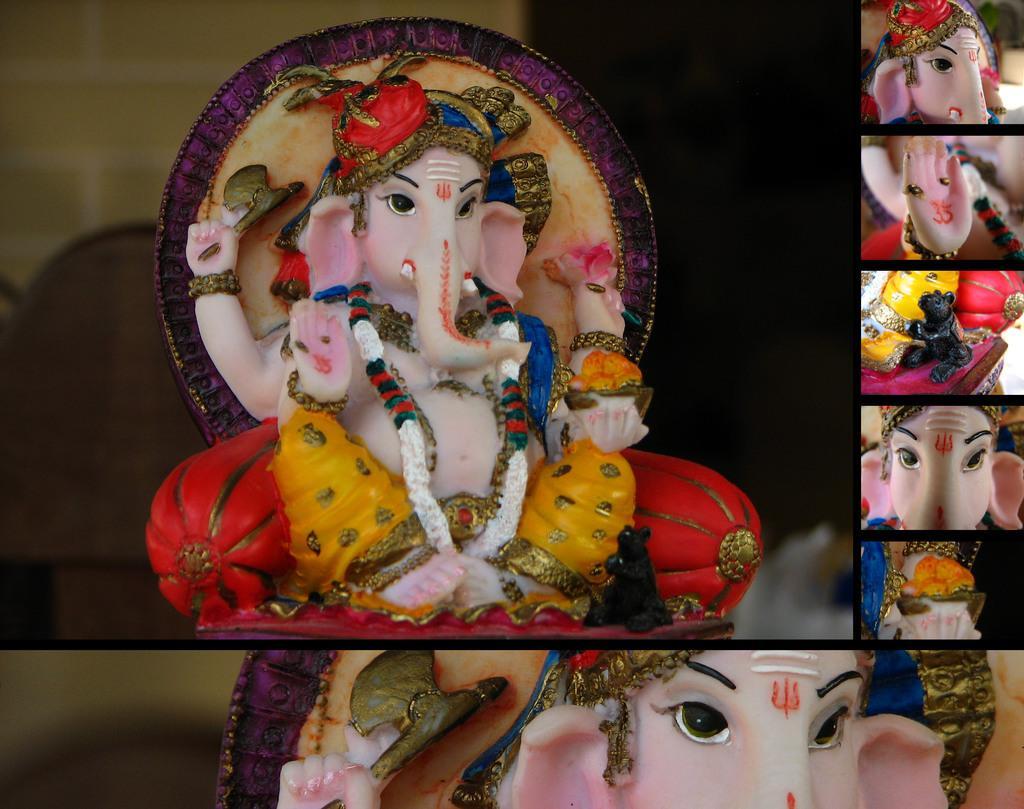Can you describe this image briefly? In the image I can see idols of god. This image is a collage picture. 